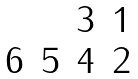Convert formula to latex. <formula><loc_0><loc_0><loc_500><loc_500>\begin{matrix} & & 3 & 1 \\ 6 & 5 & 4 & 2 \\ \end{matrix}</formula> 